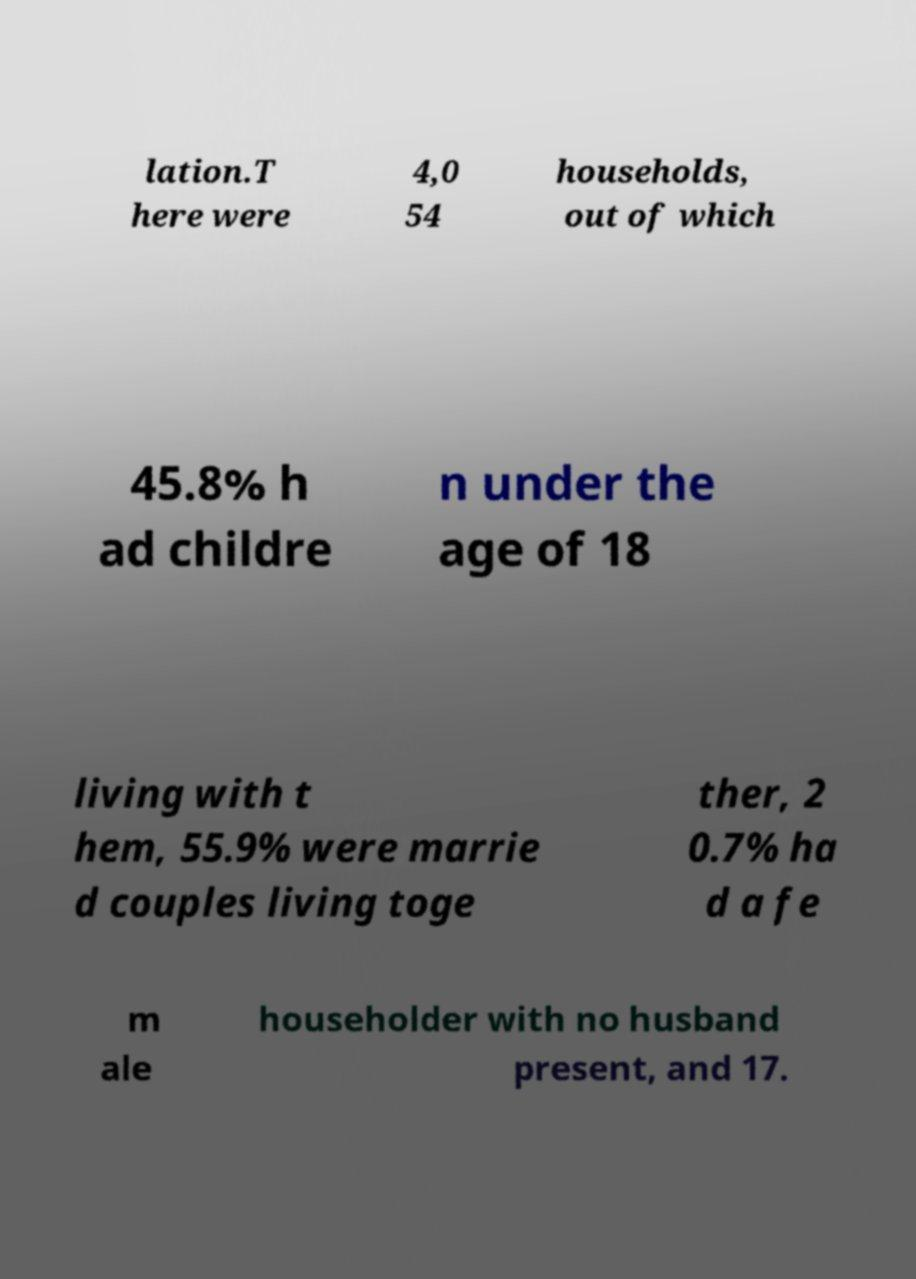Please read and relay the text visible in this image. What does it say? lation.T here were 4,0 54 households, out of which 45.8% h ad childre n under the age of 18 living with t hem, 55.9% were marrie d couples living toge ther, 2 0.7% ha d a fe m ale householder with no husband present, and 17. 